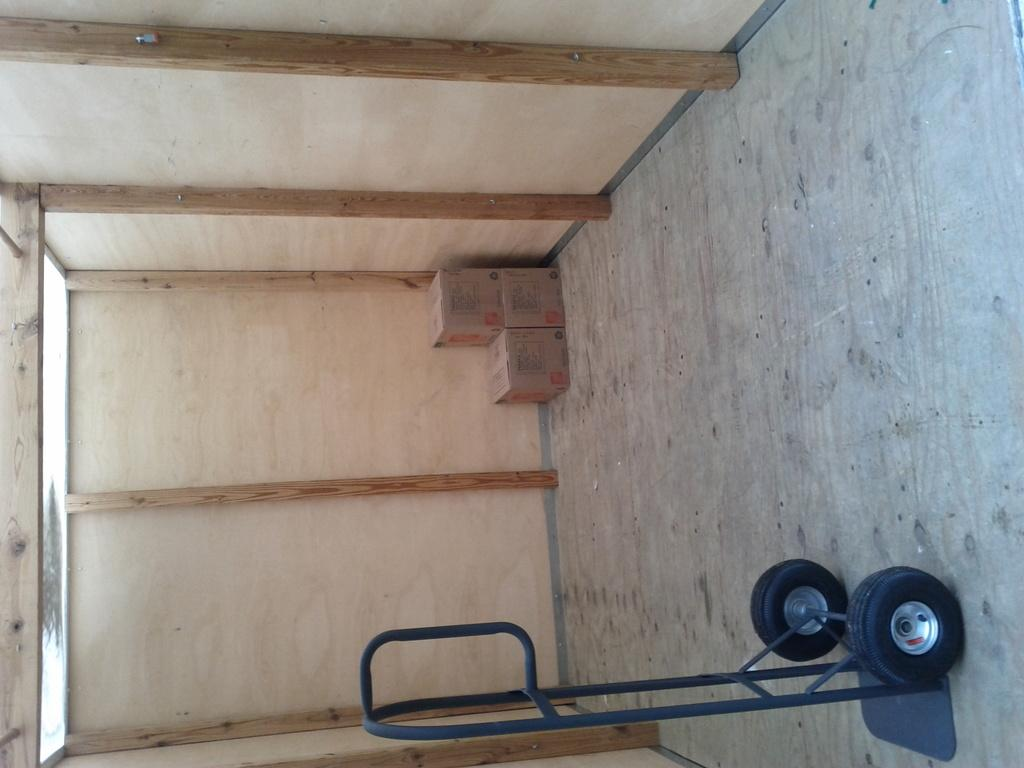What object is on the floor in the image? There is a cart on the floor. What can be seen in the background of the image? There are cardboard boxes and a wooden wall in the background. What type of ornament is hanging from the wooden wall in the image? There is no ornament hanging from the wooden wall in the image; only cardboard boxes and the wooden wall are present. 